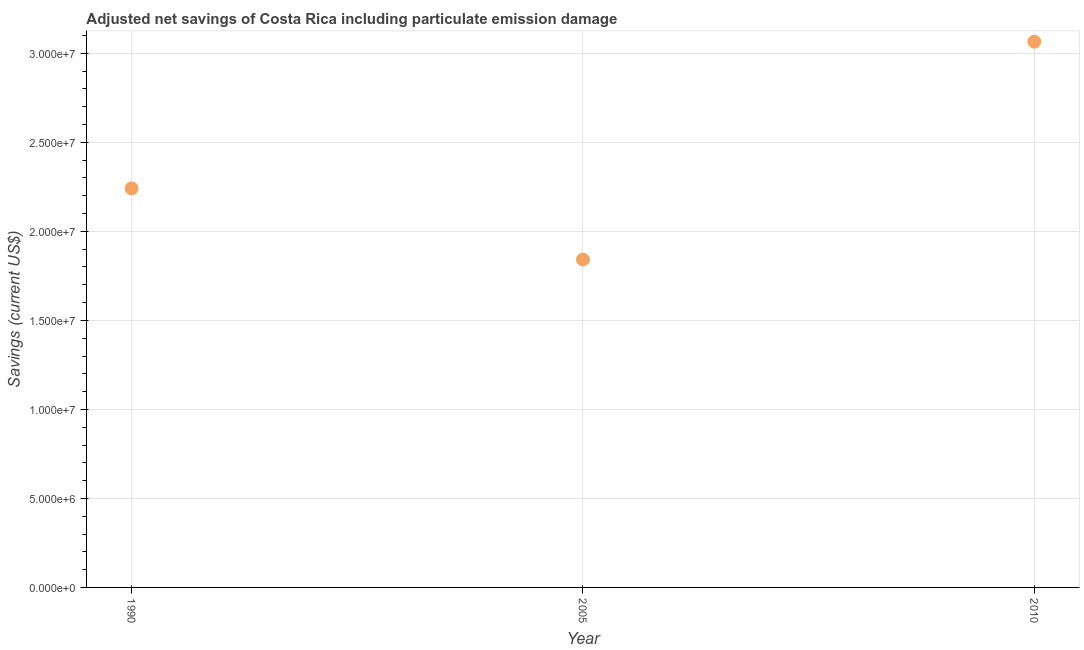What is the adjusted net savings in 2005?
Keep it short and to the point. 1.84e+07. Across all years, what is the maximum adjusted net savings?
Your answer should be very brief. 3.07e+07. Across all years, what is the minimum adjusted net savings?
Offer a terse response. 1.84e+07. In which year was the adjusted net savings maximum?
Your response must be concise. 2010. In which year was the adjusted net savings minimum?
Offer a very short reply. 2005. What is the sum of the adjusted net savings?
Keep it short and to the point. 7.15e+07. What is the difference between the adjusted net savings in 2005 and 2010?
Give a very brief answer. -1.22e+07. What is the average adjusted net savings per year?
Provide a short and direct response. 2.38e+07. What is the median adjusted net savings?
Offer a terse response. 2.24e+07. Do a majority of the years between 1990 and 2010 (inclusive) have adjusted net savings greater than 15000000 US$?
Provide a short and direct response. Yes. What is the ratio of the adjusted net savings in 1990 to that in 2010?
Your answer should be compact. 0.73. Is the adjusted net savings in 1990 less than that in 2005?
Provide a short and direct response. No. Is the difference between the adjusted net savings in 1990 and 2010 greater than the difference between any two years?
Provide a short and direct response. No. What is the difference between the highest and the second highest adjusted net savings?
Your answer should be very brief. 8.24e+06. What is the difference between the highest and the lowest adjusted net savings?
Make the answer very short. 1.22e+07. In how many years, is the adjusted net savings greater than the average adjusted net savings taken over all years?
Your answer should be very brief. 1. Does the adjusted net savings monotonically increase over the years?
Keep it short and to the point. No. How many years are there in the graph?
Your response must be concise. 3. What is the difference between two consecutive major ticks on the Y-axis?
Give a very brief answer. 5.00e+06. Does the graph contain any zero values?
Your answer should be very brief. No. What is the title of the graph?
Give a very brief answer. Adjusted net savings of Costa Rica including particulate emission damage. What is the label or title of the X-axis?
Provide a short and direct response. Year. What is the label or title of the Y-axis?
Make the answer very short. Savings (current US$). What is the Savings (current US$) in 1990?
Your answer should be compact. 2.24e+07. What is the Savings (current US$) in 2005?
Your answer should be compact. 1.84e+07. What is the Savings (current US$) in 2010?
Give a very brief answer. 3.07e+07. What is the difference between the Savings (current US$) in 1990 and 2005?
Provide a succinct answer. 3.99e+06. What is the difference between the Savings (current US$) in 1990 and 2010?
Your answer should be very brief. -8.24e+06. What is the difference between the Savings (current US$) in 2005 and 2010?
Offer a terse response. -1.22e+07. What is the ratio of the Savings (current US$) in 1990 to that in 2005?
Provide a succinct answer. 1.22. What is the ratio of the Savings (current US$) in 1990 to that in 2010?
Give a very brief answer. 0.73. What is the ratio of the Savings (current US$) in 2005 to that in 2010?
Make the answer very short. 0.6. 